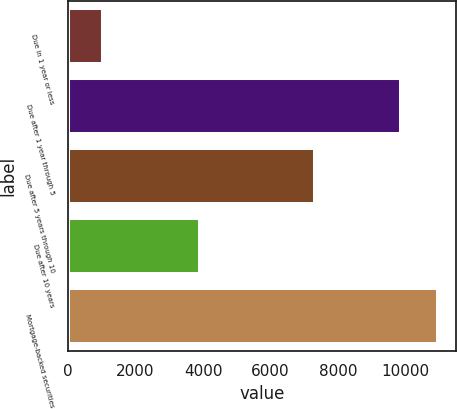Convert chart to OTSL. <chart><loc_0><loc_0><loc_500><loc_500><bar_chart><fcel>Due in 1 year or less<fcel>Due after 1 year through 5<fcel>Due after 5 years through 10<fcel>Due after 10 years<fcel>Mortgage-backed securities<nl><fcel>1047<fcel>9868<fcel>7330<fcel>3906<fcel>10958<nl></chart> 